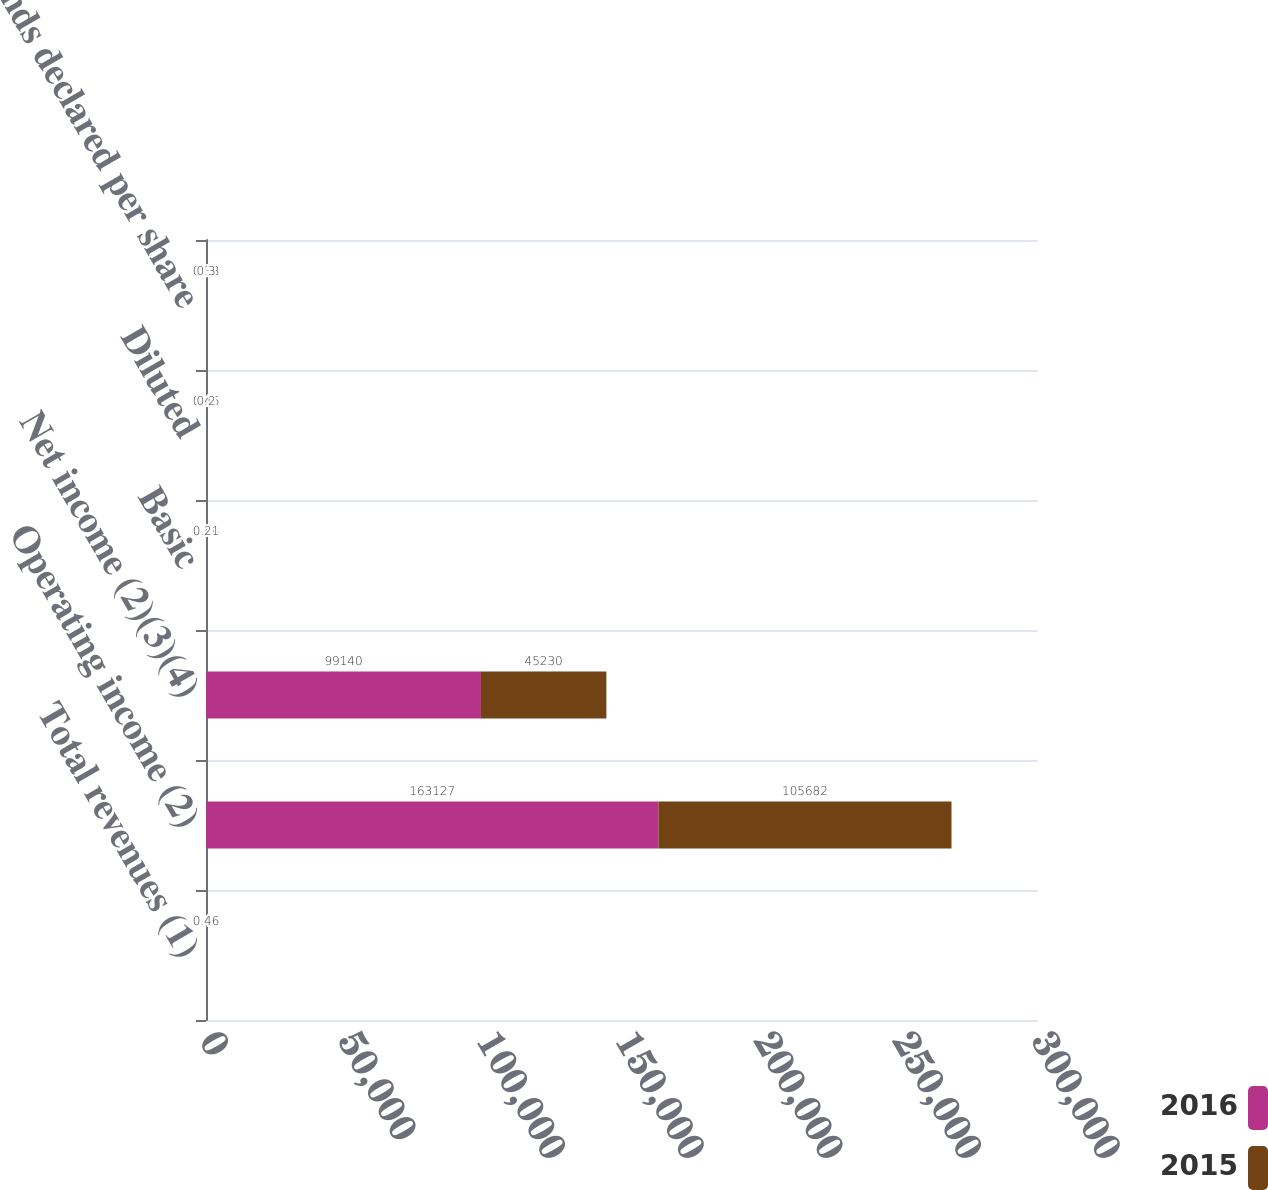Convert chart to OTSL. <chart><loc_0><loc_0><loc_500><loc_500><stacked_bar_chart><ecel><fcel>Total revenues (1)<fcel>Operating income (2)<fcel>Net income (2)(3)(4)<fcel>Basic<fcel>Diluted<fcel>Dividends declared per share<nl><fcel>2016<fcel>0.46<fcel>163127<fcel>99140<fcel>0.46<fcel>0.46<fcel>0.38<nl><fcel>2015<fcel>0.46<fcel>105682<fcel>45230<fcel>0.21<fcel>0.2<fcel>0.3<nl></chart> 